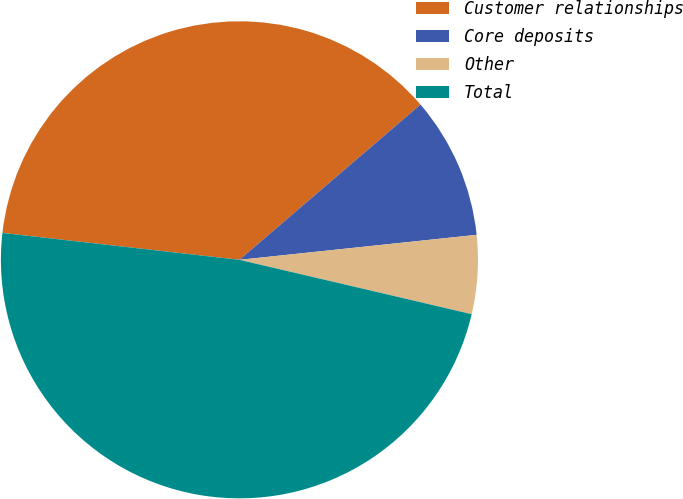Convert chart to OTSL. <chart><loc_0><loc_0><loc_500><loc_500><pie_chart><fcel>Customer relationships<fcel>Core deposits<fcel>Other<fcel>Total<nl><fcel>36.92%<fcel>9.61%<fcel>5.33%<fcel>48.14%<nl></chart> 